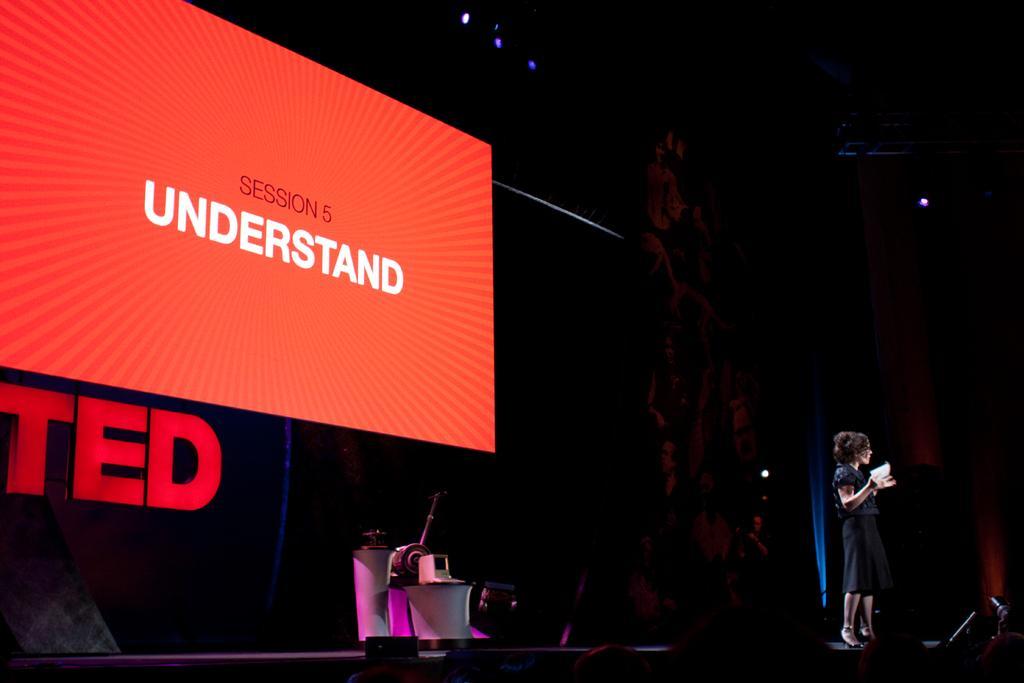Please provide a concise description of this image. In this picture I can see a woman standing, there are focus lights, there are some objects on the tables, there is another person standing, there is a mike with a mike stand, and in the background there is a screen. 